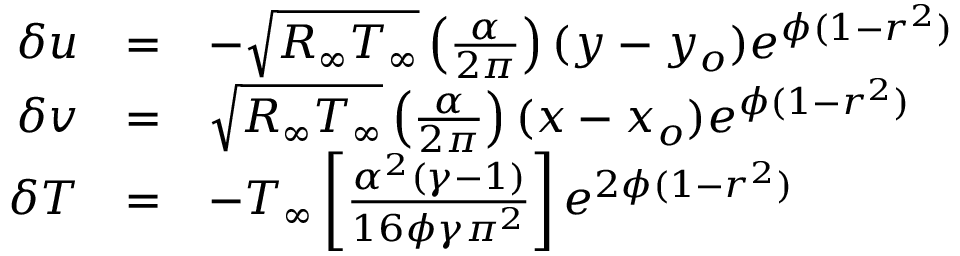<formula> <loc_0><loc_0><loc_500><loc_500>\begin{array} { r } { \begin{array} { r c l } { \delta u } & { = } & { - \sqrt { R _ { \infty } T _ { \infty } } \left ( \frac { \alpha } { 2 \pi } \right ) ( y - y _ { o } ) e ^ { \phi ( 1 - r ^ { 2 } ) } } \\ { \delta v } & { = } & { \sqrt { R _ { \infty } T _ { \infty } } \left ( \frac { \alpha } { 2 \pi } \right ) ( x - x _ { o } ) e ^ { \phi ( 1 - r ^ { 2 } ) } } \\ { \delta T } & { = } & { - T _ { \infty } \left [ \frac { \alpha ^ { 2 } ( \gamma - 1 ) } { 1 6 \phi \gamma \pi ^ { 2 } } \right ] e ^ { 2 \phi ( 1 - r ^ { 2 } ) } } \end{array} } \end{array}</formula> 